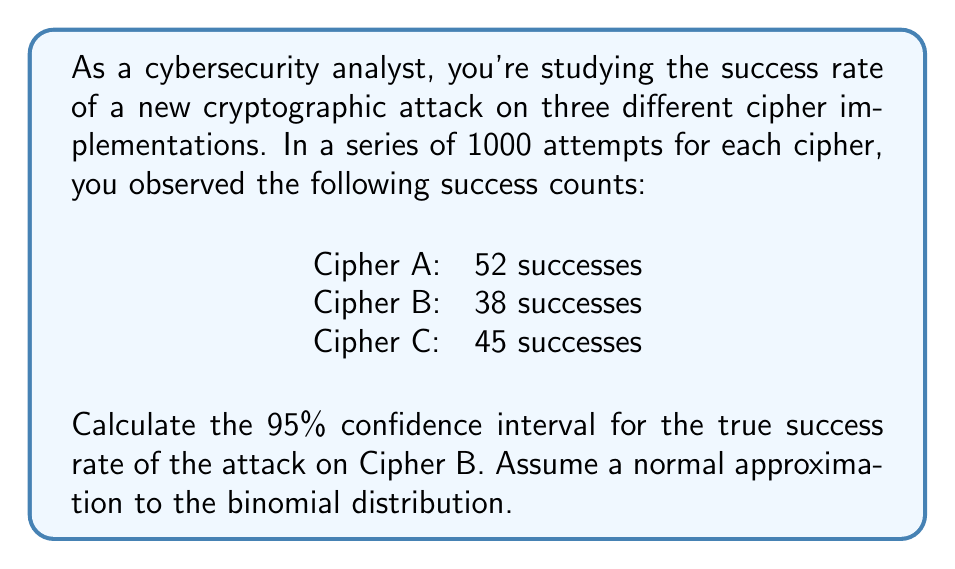Solve this math problem. To calculate the 95% confidence interval for the success rate of the attack on Cipher B, we'll follow these steps:

1. Calculate the point estimate (sample proportion):
   $\hat{p} = \frac{\text{number of successes}}{\text{total attempts}} = \frac{38}{1000} = 0.038$

2. Determine the z-score for a 95% confidence interval:
   For a 95% CI, $z = 1.96$

3. Calculate the standard error of the proportion:
   $SE = \sqrt{\frac{\hat{p}(1-\hat{p})}{n}} = \sqrt{\frac{0.038(1-0.038)}{1000}} = 0.00603$

4. Compute the margin of error:
   $ME = z \times SE = 1.96 \times 0.00603 = 0.01182$

5. Calculate the confidence interval:
   Lower bound: $\hat{p} - ME = 0.038 - 0.01182 = 0.02618$
   Upper bound: $\hat{p} + ME = 0.038 + 0.01182 = 0.04982$

Therefore, the 95% confidence interval for the true success rate of the attack on Cipher B is (0.02618, 0.04982) or (2.62%, 4.98%).

This means we can be 95% confident that the true success rate of the cryptographic attack on Cipher B lies between 2.62% and 4.98%.
Answer: (0.02618, 0.04982) or (2.62%, 4.98%) 